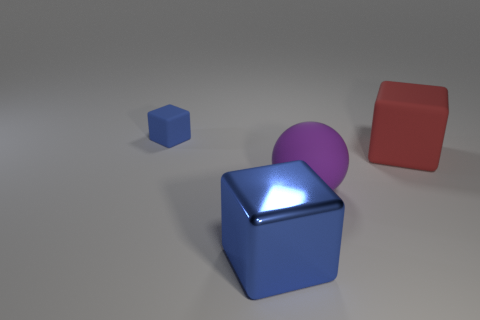Add 4 big blue shiny things. How many objects exist? 8 Subtract all cubes. How many objects are left? 1 Add 1 large metal blocks. How many large metal blocks exist? 2 Subtract 0 brown cylinders. How many objects are left? 4 Subtract all small red cylinders. Subtract all blue metal objects. How many objects are left? 3 Add 4 blue shiny blocks. How many blue shiny blocks are left? 5 